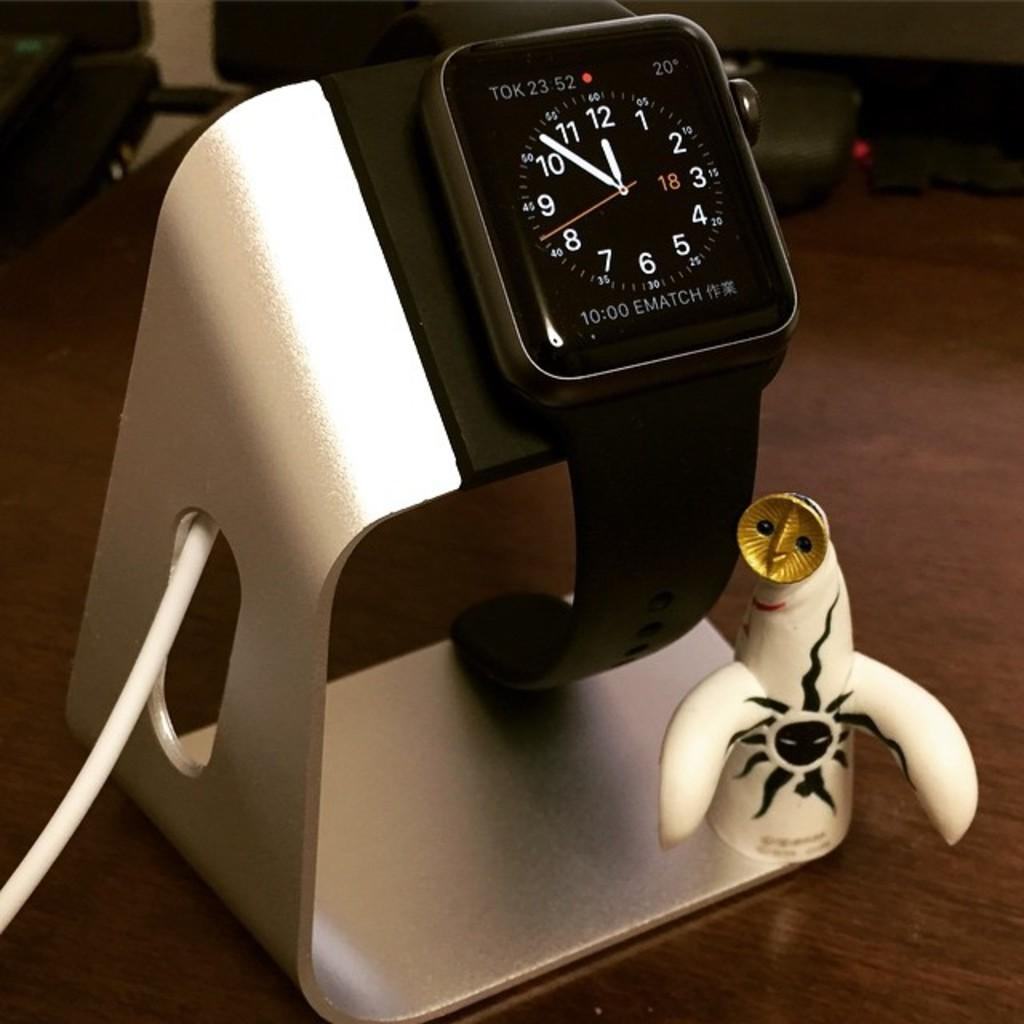Provide a one-sentence caption for the provided image. A smart watch reading 11:52 sits on a novelty charging station. 